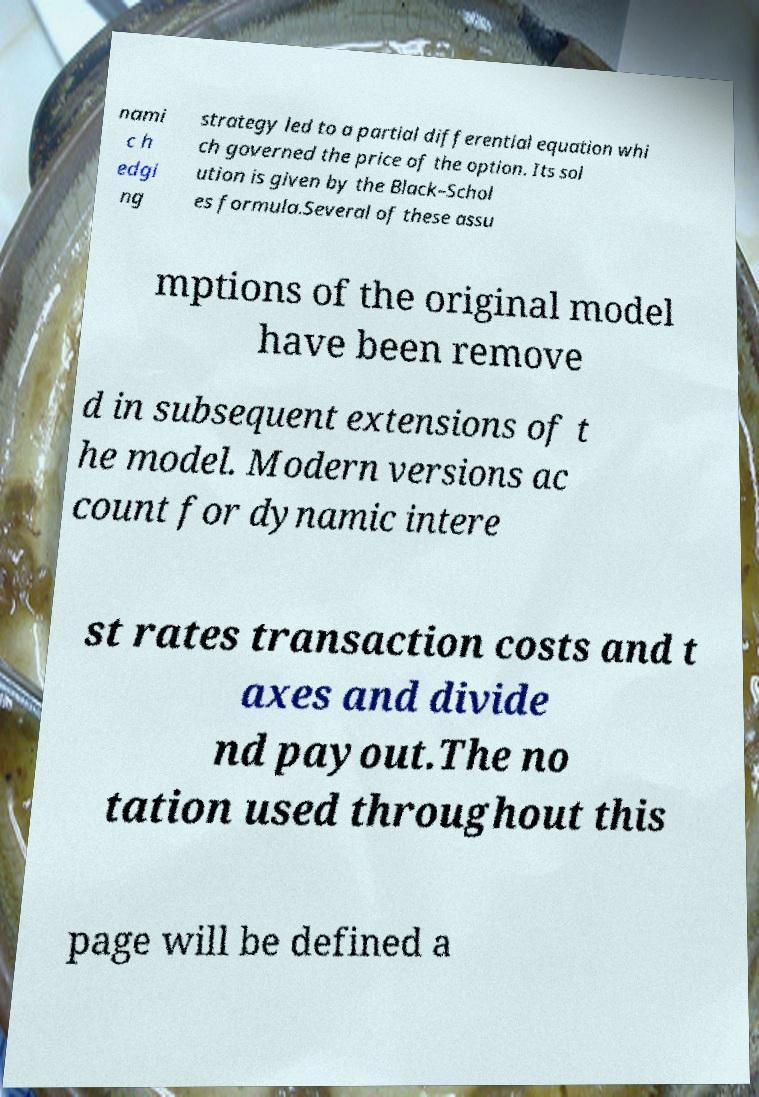For documentation purposes, I need the text within this image transcribed. Could you provide that? nami c h edgi ng strategy led to a partial differential equation whi ch governed the price of the option. Its sol ution is given by the Black–Schol es formula.Several of these assu mptions of the original model have been remove d in subsequent extensions of t he model. Modern versions ac count for dynamic intere st rates transaction costs and t axes and divide nd payout.The no tation used throughout this page will be defined a 